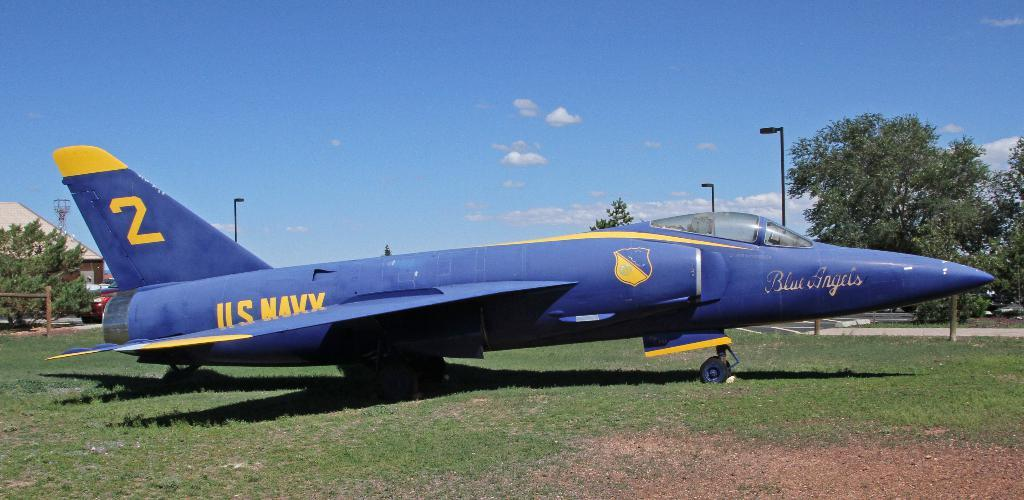What type of airplane is in the foreground of the image? There is a navy airplane in the foreground of the image. Where is the airplane located? The airplane is on the grass. What can be seen in the background of the image? There are poles, trees, a vehicle, a building, and the sky visible in the background of the image. Can you describe the sky in the image? The sky is visible in the background of the image, and there is a cloud present. How many cows are standing in a circle around the airplane in the image? There are no cows present in the image, and therefore no cows are standing in a circle around the airplane. 